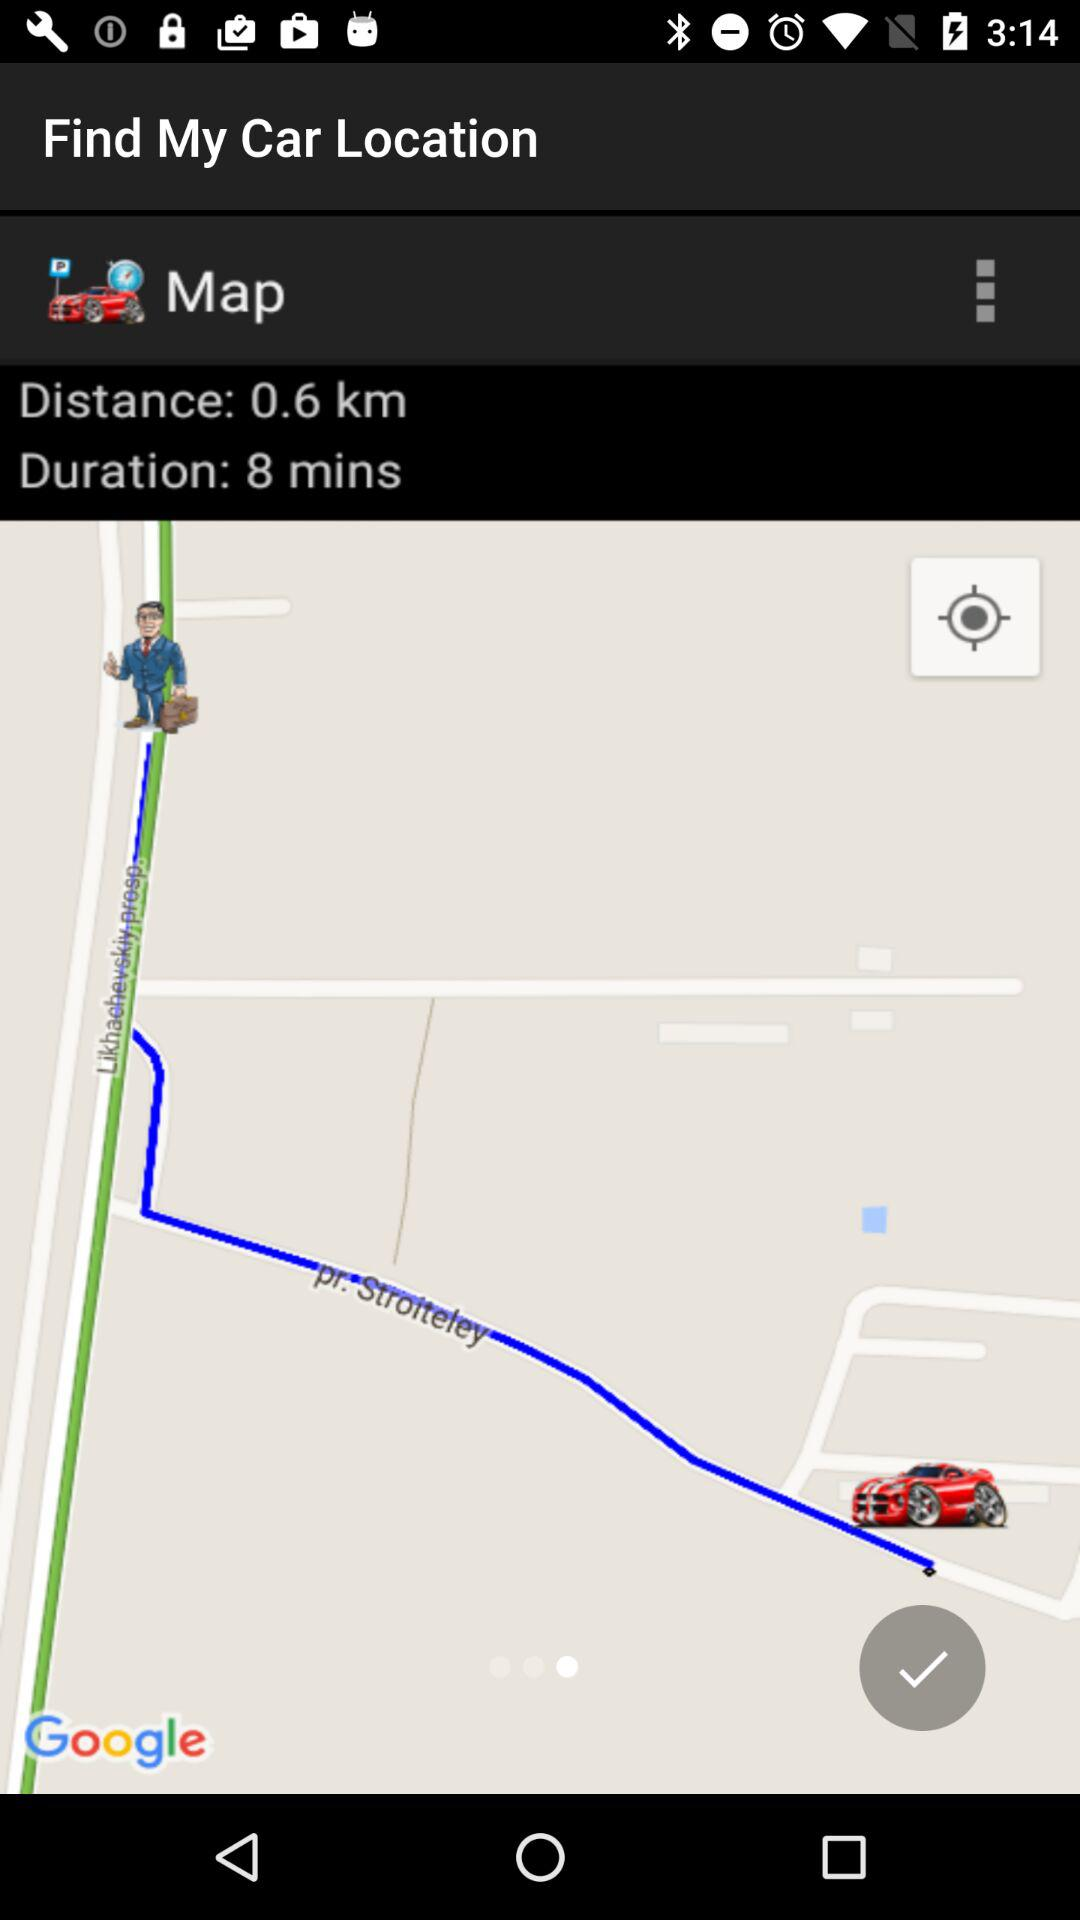How far away is my car?
Answer the question using a single word or phrase. 0.6 km 